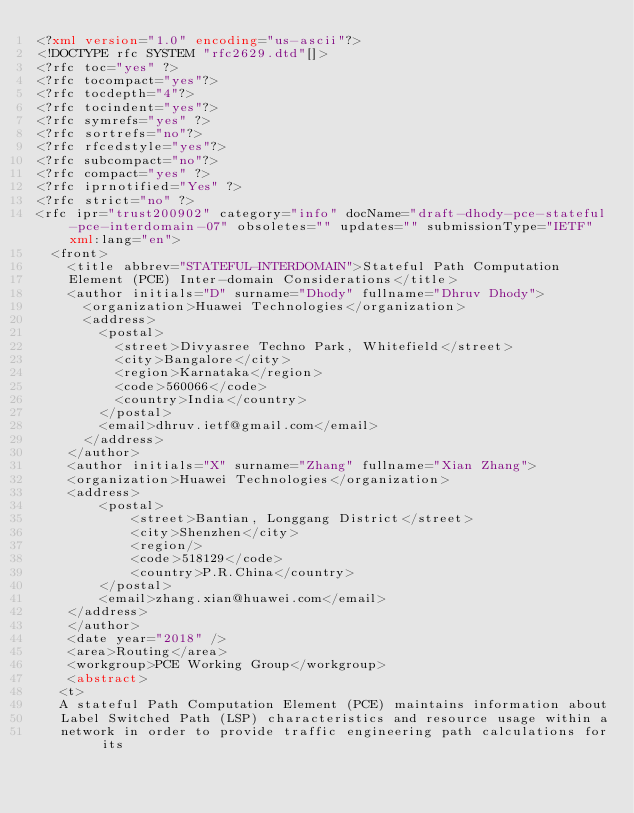<code> <loc_0><loc_0><loc_500><loc_500><_XML_><?xml version="1.0" encoding="us-ascii"?>
<!DOCTYPE rfc SYSTEM "rfc2629.dtd"[]>
<?rfc toc="yes" ?>
<?rfc tocompact="yes"?>
<?rfc tocdepth="4"?>
<?rfc tocindent="yes"?>
<?rfc symrefs="yes" ?>
<?rfc sortrefs="no"?>
<?rfc rfcedstyle="yes"?>
<?rfc subcompact="no"?>
<?rfc compact="yes" ?>
<?rfc iprnotified="Yes" ?>
<?rfc strict="no" ?>
<rfc ipr="trust200902" category="info" docName="draft-dhody-pce-stateful-pce-interdomain-07" obsoletes="" updates="" submissionType="IETF" xml:lang="en">
  <front>
    <title abbrev="STATEFUL-INTERDOMAIN">Stateful Path Computation 
    Element (PCE) Inter-domain Considerations</title>
    <author initials="D" surname="Dhody" fullname="Dhruv Dhody">
      <organization>Huawei Technologies</organization>
      <address>
        <postal>
          <street>Divyasree Techno Park, Whitefield</street>
          <city>Bangalore</city>
          <region>Karnataka</region>
          <code>560066</code>
          <country>India</country>
        </postal>
        <email>dhruv.ietf@gmail.com</email>
      </address>
    </author>
	<author initials="X" surname="Zhang" fullname="Xian Zhang">
	<organization>Huawei Technologies</organization>
	<address>
		<postal>
			<street>Bantian, Longgang District</street>
			<city>Shenzhen</city>
			<region/>
			<code>518129</code>
			<country>P.R.China</country>
		</postal>
		<email>zhang.xian@huawei.com</email>
	</address>
	</author>
    <date year="2018" />
    <area>Routing</area>
    <workgroup>PCE Working Group</workgroup>
    <abstract>
   <t> 
   A stateful Path Computation Element (PCE) maintains information about
   Label Switched Path (LSP) characteristics and resource usage within a
   network in order to provide traffic engineering path calculations for its</code> 